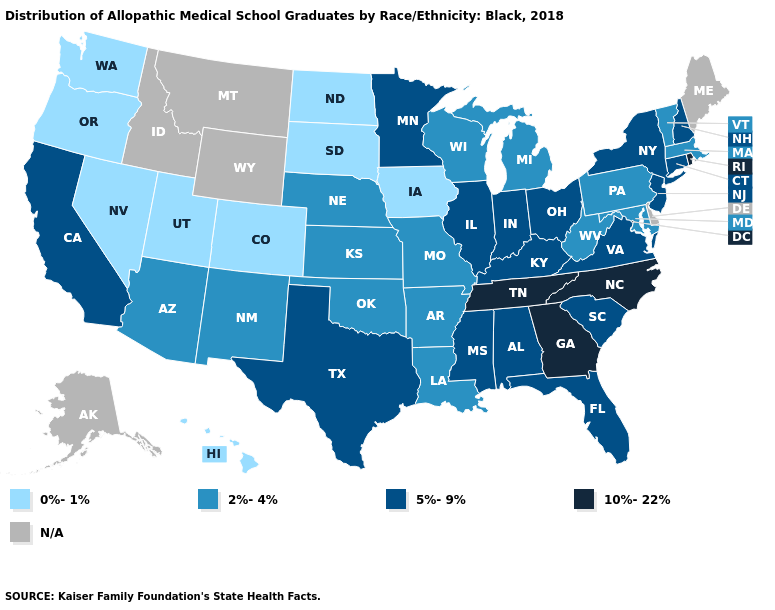What is the value of Alabama?
Concise answer only. 5%-9%. Among the states that border Oklahoma , does Arkansas have the lowest value?
Short answer required. No. What is the lowest value in states that border Iowa?
Answer briefly. 0%-1%. Name the states that have a value in the range 2%-4%?
Be succinct. Arizona, Arkansas, Kansas, Louisiana, Maryland, Massachusetts, Michigan, Missouri, Nebraska, New Mexico, Oklahoma, Pennsylvania, Vermont, West Virginia, Wisconsin. How many symbols are there in the legend?
Be succinct. 5. Name the states that have a value in the range 5%-9%?
Give a very brief answer. Alabama, California, Connecticut, Florida, Illinois, Indiana, Kentucky, Minnesota, Mississippi, New Hampshire, New Jersey, New York, Ohio, South Carolina, Texas, Virginia. What is the value of Arkansas?
Short answer required. 2%-4%. What is the value of Massachusetts?
Be succinct. 2%-4%. What is the highest value in the West ?
Concise answer only. 5%-9%. Does Rhode Island have the highest value in the Northeast?
Quick response, please. Yes. Name the states that have a value in the range N/A?
Keep it brief. Alaska, Delaware, Idaho, Maine, Montana, Wyoming. Which states hav the highest value in the West?
Short answer required. California. Name the states that have a value in the range 0%-1%?
Short answer required. Colorado, Hawaii, Iowa, Nevada, North Dakota, Oregon, South Dakota, Utah, Washington. Does Nevada have the lowest value in the USA?
Keep it brief. Yes. 